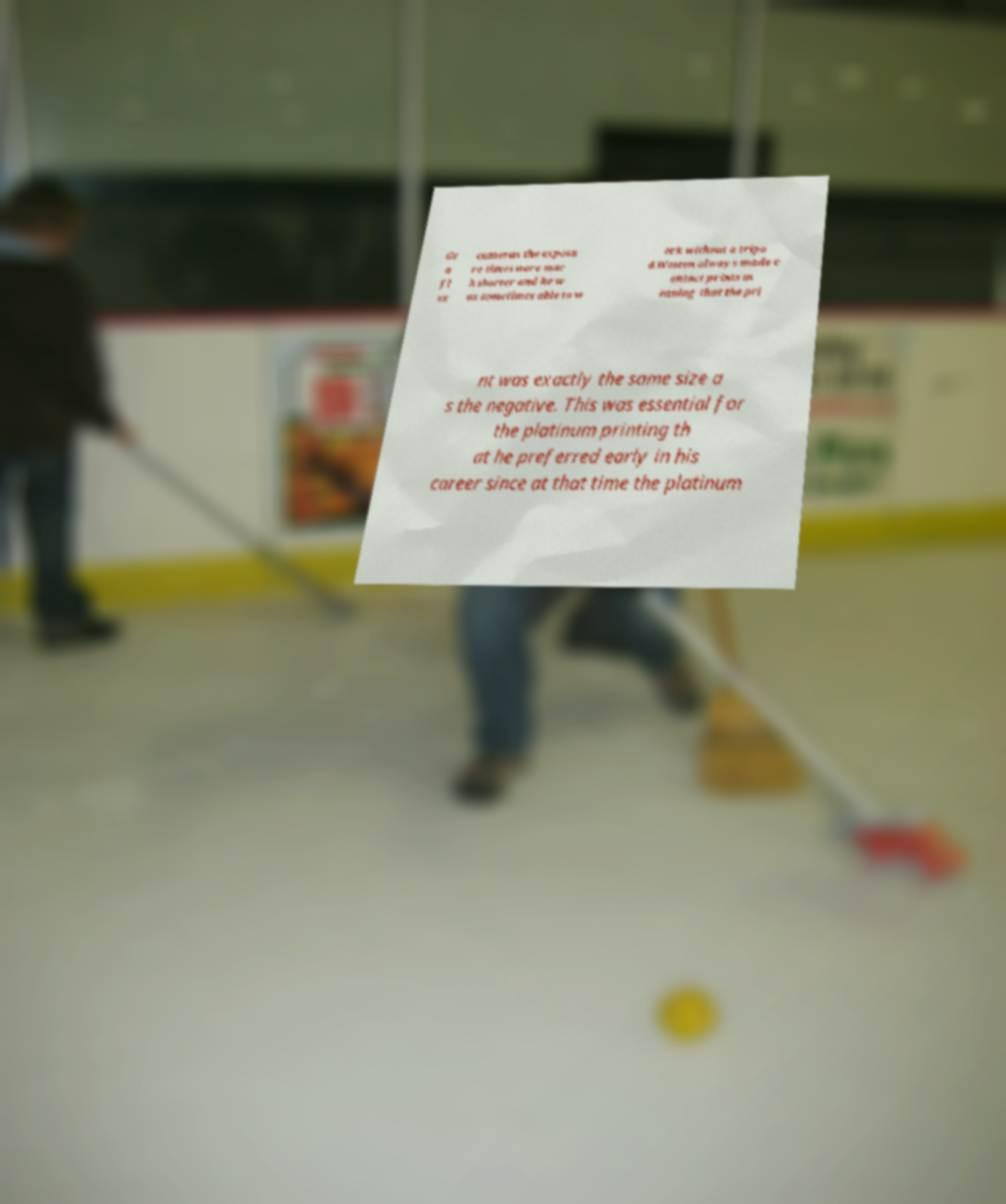Could you assist in decoding the text presented in this image and type it out clearly? Gr a fl ex cameras the exposu re times were muc h shorter and he w as sometimes able to w ork without a tripo d.Weston always made c ontact prints m eaning that the pri nt was exactly the same size a s the negative. This was essential for the platinum printing th at he preferred early in his career since at that time the platinum 